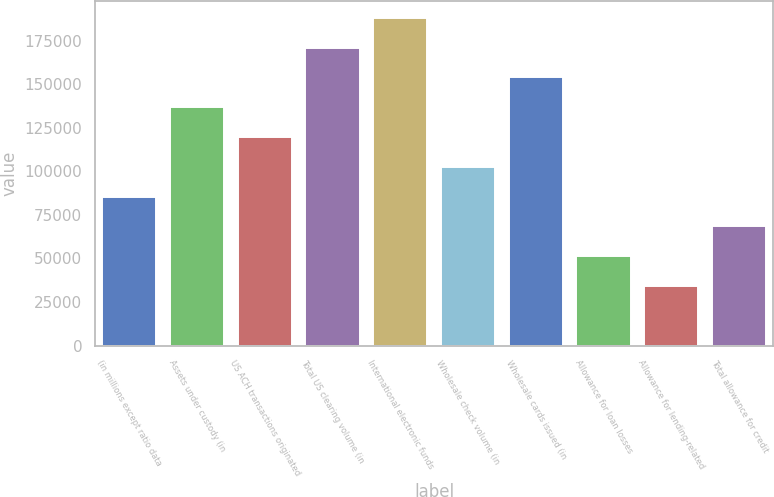Convert chart. <chart><loc_0><loc_0><loc_500><loc_500><bar_chart><fcel>(in millions except ratio data<fcel>Assets under custody (in<fcel>US ACH transactions originated<fcel>Total US clearing volume (in<fcel>International electronic funds<fcel>Wholesale check volume (in<fcel>Wholesale cards issued (in<fcel>Allowance for loan losses<fcel>Allowance for lending-related<fcel>Total allowance for credit<nl><fcel>85518.1<fcel>136829<fcel>119725<fcel>171036<fcel>188140<fcel>102622<fcel>153932<fcel>51311<fcel>34207.4<fcel>68414.6<nl></chart> 